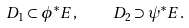Convert formula to latex. <formula><loc_0><loc_0><loc_500><loc_500>D _ { 1 } \subset \phi ^ { * } E , \quad D _ { 2 } \supset \psi ^ { * } E .</formula> 